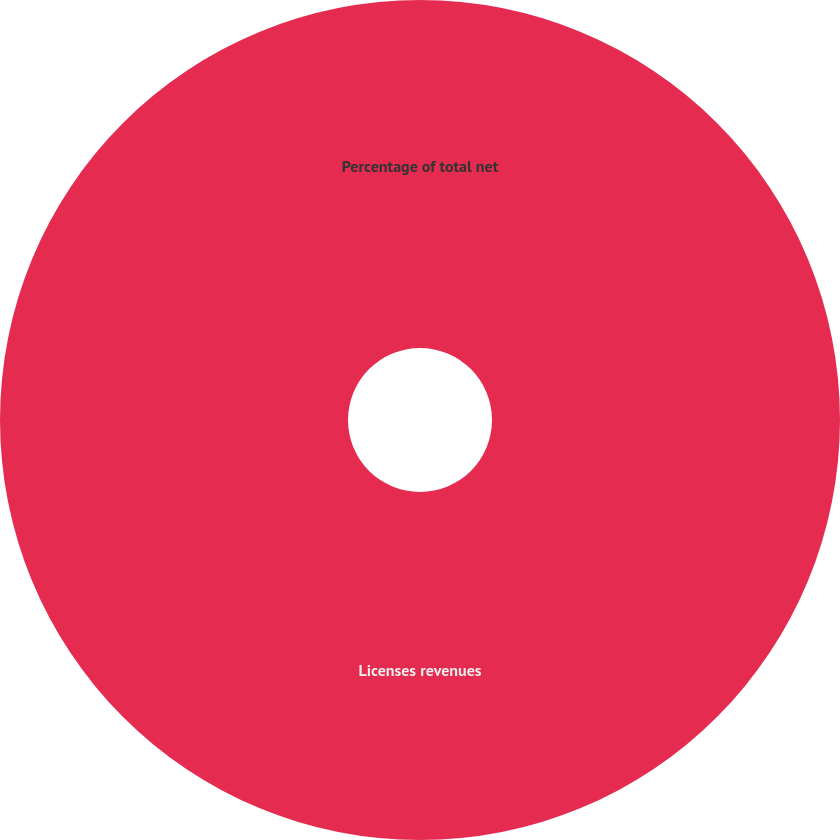<chart> <loc_0><loc_0><loc_500><loc_500><pie_chart><fcel>Licenses revenues<fcel>Percentage of total net<nl><fcel>100.0%<fcel>0.0%<nl></chart> 